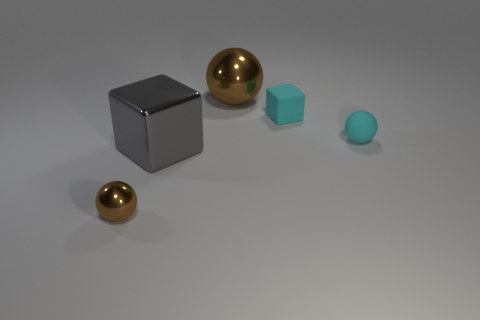There is a small sphere that is behind the tiny brown metallic thing; what number of small cubes are behind it?
Offer a terse response. 1. Are there any large shiny blocks of the same color as the small metal sphere?
Provide a succinct answer. No. Do the gray block and the cyan ball have the same size?
Your answer should be compact. No. Do the large metal cube and the tiny rubber cube have the same color?
Give a very brief answer. No. What material is the block that is in front of the small cyan matte object that is behind the tiny cyan sphere?
Make the answer very short. Metal. There is a cyan object that is the same shape as the gray shiny object; what material is it?
Give a very brief answer. Rubber. Does the sphere in front of the gray shiny cube have the same size as the rubber sphere?
Your response must be concise. Yes. How many matte things are brown spheres or gray cylinders?
Your answer should be compact. 0. What is the ball that is right of the small brown shiny sphere and in front of the big metallic ball made of?
Your answer should be very brief. Rubber. Is the large gray cube made of the same material as the cyan cube?
Ensure brevity in your answer.  No. 